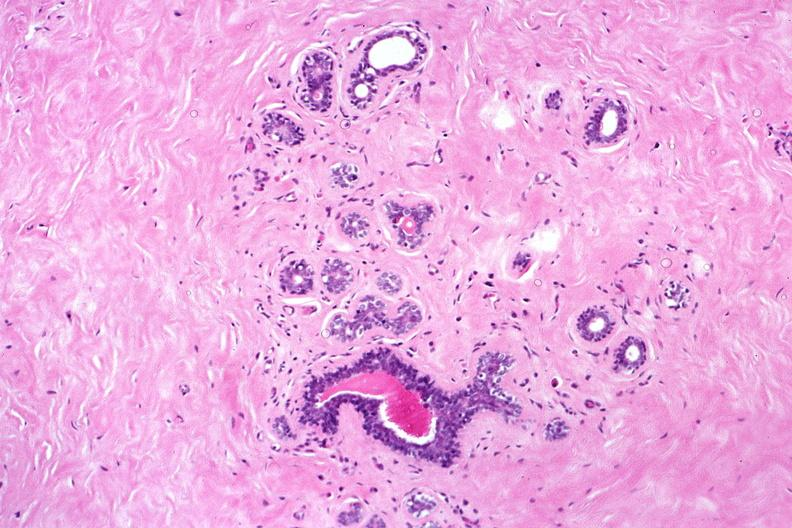s female reproductive present?
Answer the question using a single word or phrase. Yes 